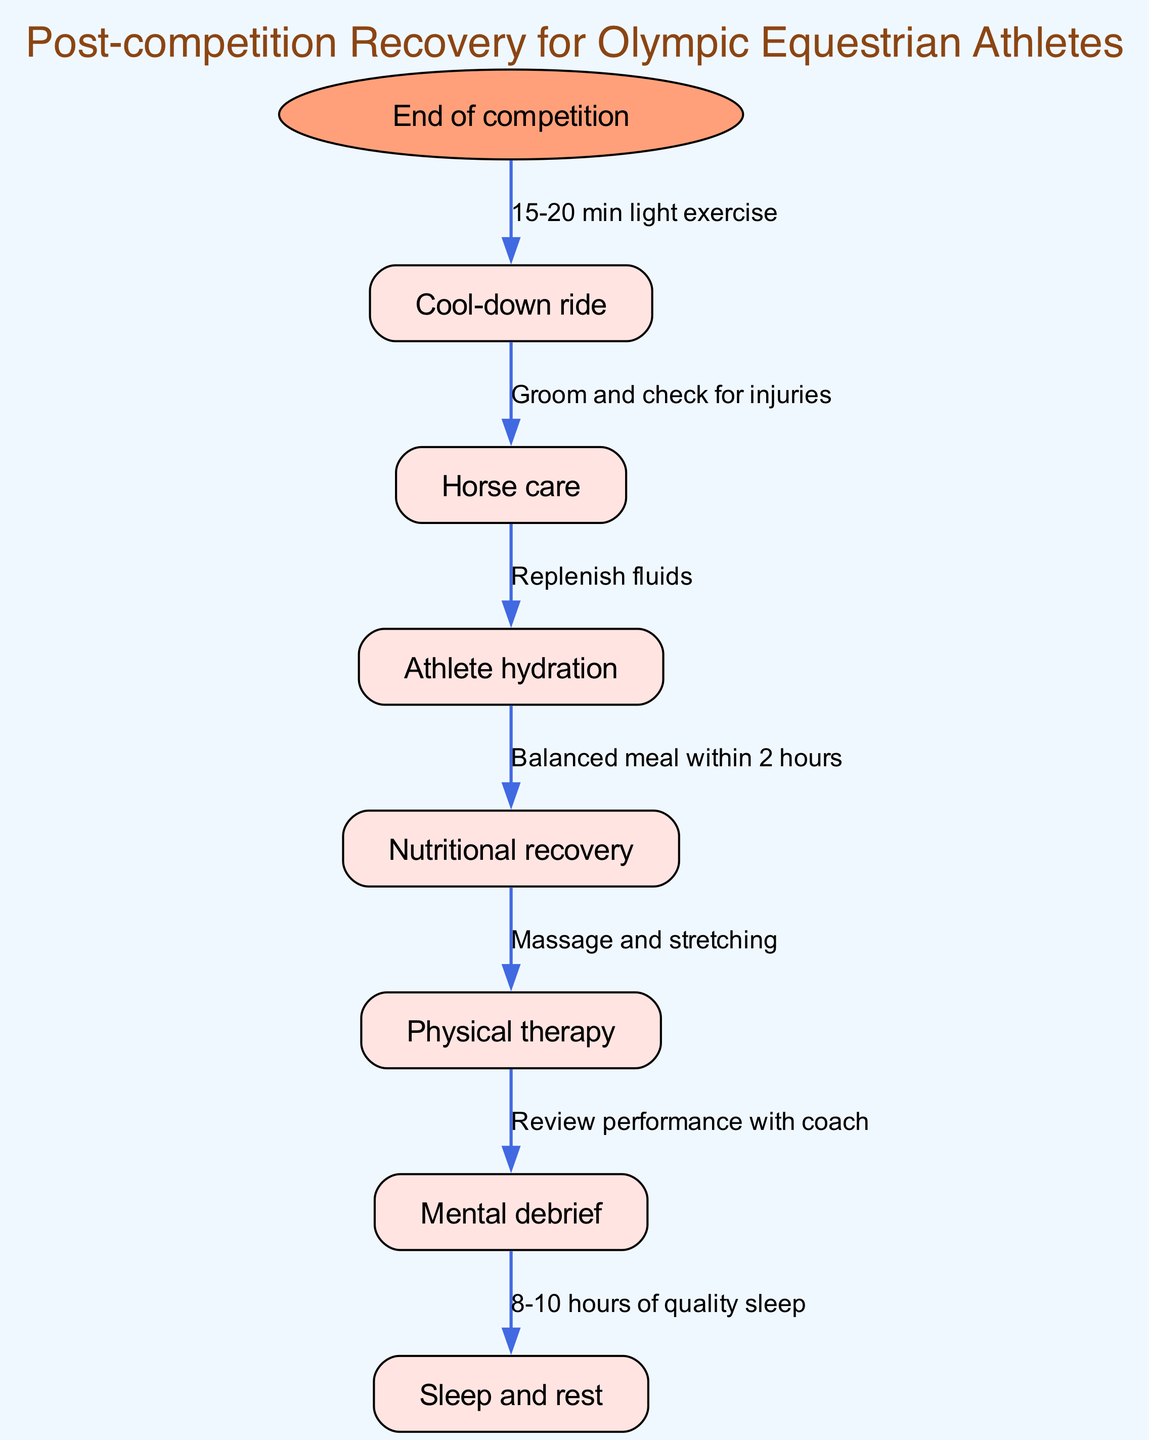What is the starting point of the clinical pathway? The diagram indicates that the starting point is labeled "End of competition." This is specified at the top of the flow diagram as the starting node.
Answer: End of competition How many nodes are there in the pathway? The diagram includes a total of seven nodes: "End of competition," "Cool-down ride," "Horse care," "Athlete hydration," "Nutritional recovery," "Physical therapy," and "Mental debrief." Counting all nodes yields seven.
Answer: 7 What follows the “Horse care” step? According to the diagram, after the "Horse care" node, the next step in the pathway is "Athlete hydration." This is indicated by the directed edge connecting these two nodes.
Answer: Athlete hydration What is recommended after “Cool-down ride”? The pathway specifies that after the "Cool-down ride," the next step is "Horse care." The connection shows the flow from one step to the next clearly.
Answer: Horse care What is the minimum recommended sleep duration after the mental debrief? The diagram states that the recommended sleep duration after the "Mental debrief" is 8-10 hours of quality sleep. This is specified clearly in the relevant edge connecting these nodes.
Answer: 8-10 hours What action is suggested before nutritional recovery? Before the "Nutritional recovery," the diagram suggests "Athlete hydration." This is indicated by the edge transition from "Athlete hydration" to "Nutritional recovery."
Answer: Athlete hydration Which step involves a review of performance? The "Mental debrief" step involves a review of performance with the coach, as indicated explicitly by the edge leading from "Physical therapy" to "Mental debrief."
Answer: Mental debrief What activity is prescribed right after the competition ends? Following the "End of competition," the diagram prescribes a "Cool-down ride," which involves 15-20 minutes of light exercise according to the connection label.
Answer: Cool-down ride 